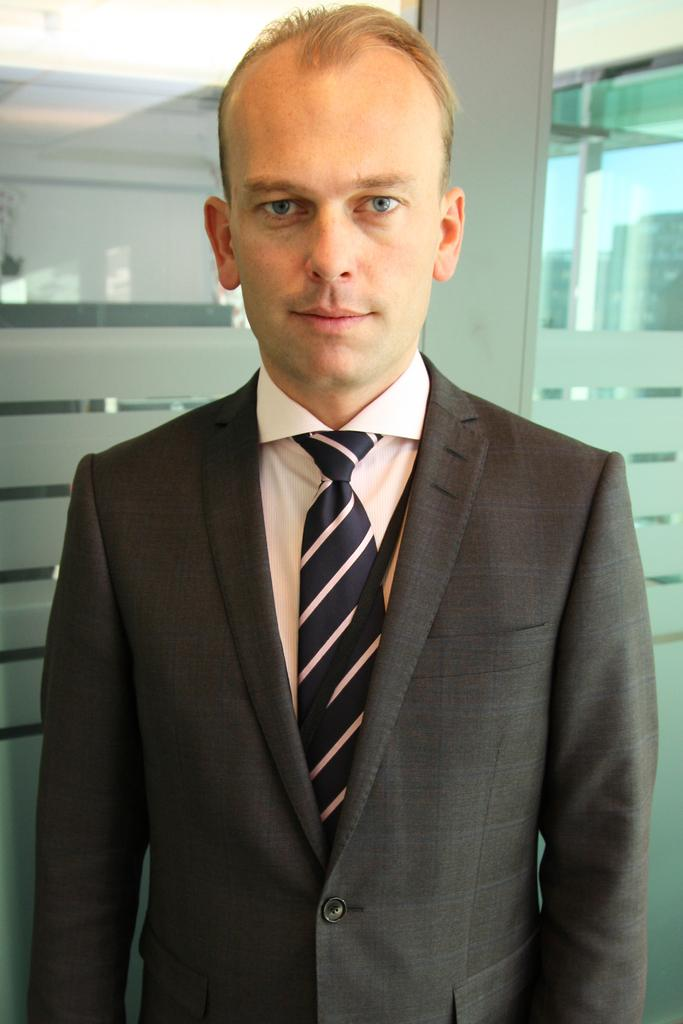What is the main subject of the image? There is a man in the image. What is the man wearing? The man is wearing a suit and a tie. What is the man's posture in the image? The man is standing. What can be seen in the background of the image? There is a glass door visible in the background. What type of tools is the man using to crack eggs in the image? There are no eggs or tools present in the image; the man is simply standing and wearing a suit and tie. 